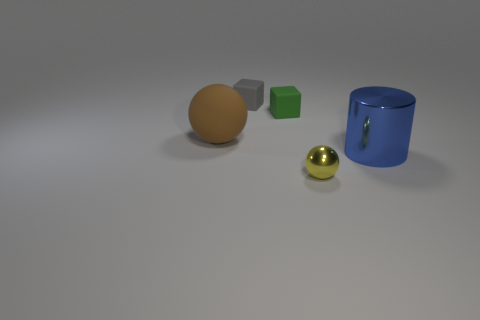Add 1 tiny rubber cubes. How many objects exist? 6 Subtract all cubes. How many objects are left? 3 Add 4 gray things. How many gray things exist? 5 Subtract 1 yellow spheres. How many objects are left? 4 Subtract all cyan cubes. Subtract all green cylinders. How many cubes are left? 2 Subtract all small green rubber balls. Subtract all large blue objects. How many objects are left? 4 Add 2 green rubber things. How many green rubber things are left? 3 